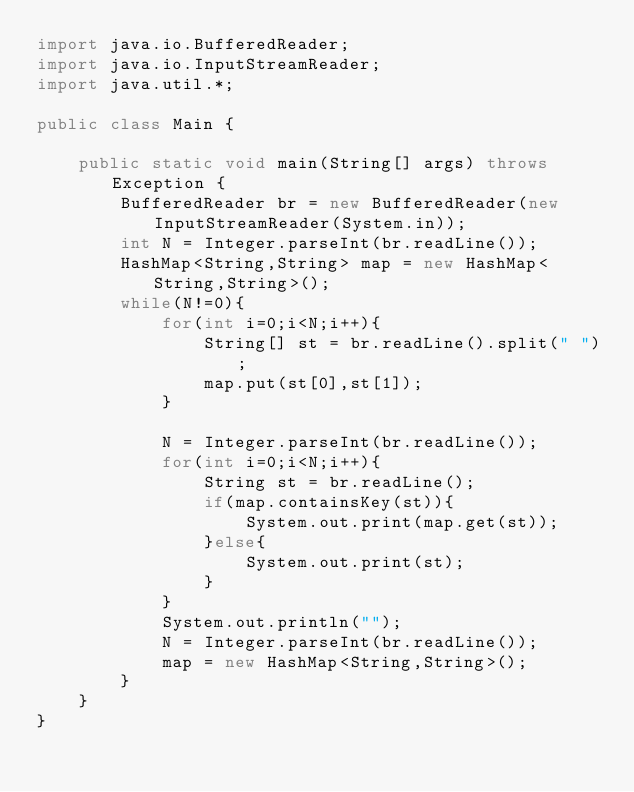Convert code to text. <code><loc_0><loc_0><loc_500><loc_500><_Java_>import java.io.BufferedReader;
import java.io.InputStreamReader;
import java.util.*;

public class Main {
    
	public static void main(String[] args) throws Exception {
		BufferedReader br = new BufferedReader(new InputStreamReader(System.in));
		int N = Integer.parseInt(br.readLine());
		HashMap<String,String> map = new HashMap<String,String>();
		while(N!=0){
			for(int i=0;i<N;i++){
				String[] st = br.readLine().split(" ");
				map.put(st[0],st[1]);
			}
			
			N = Integer.parseInt(br.readLine());
			for(int i=0;i<N;i++){
				String st = br.readLine();
				if(map.containsKey(st)){
					System.out.print(map.get(st));
				}else{
					System.out.print(st);
				}
			}
			System.out.println("");
			N = Integer.parseInt(br.readLine());
			map = new HashMap<String,String>();
		}
	}
}</code> 